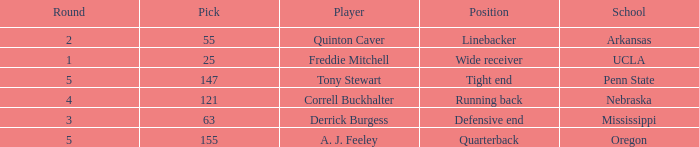What position did the player who was picked in round 3 play? Defensive end. 